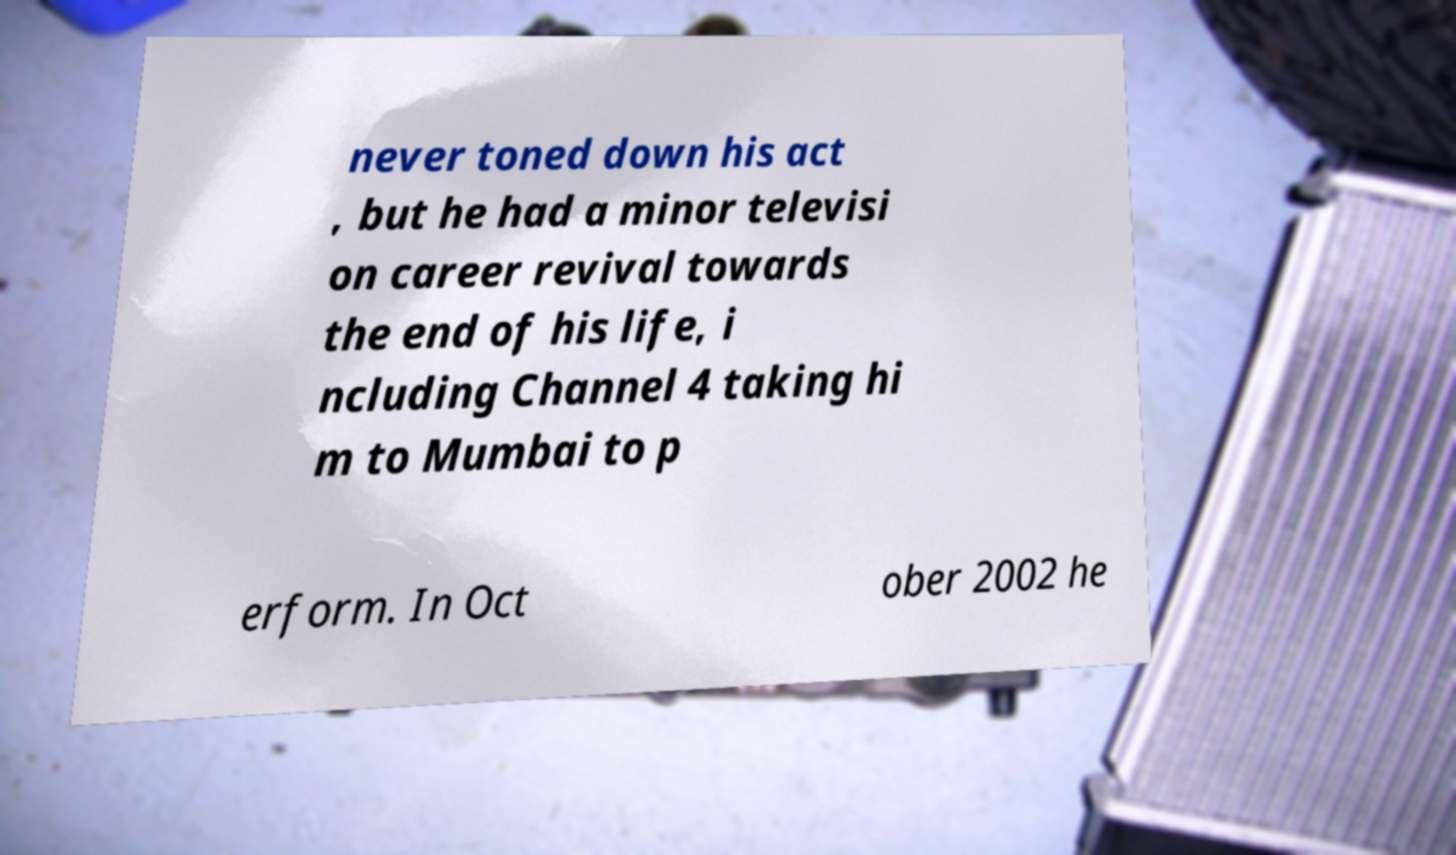Could you extract and type out the text from this image? never toned down his act , but he had a minor televisi on career revival towards the end of his life, i ncluding Channel 4 taking hi m to Mumbai to p erform. In Oct ober 2002 he 